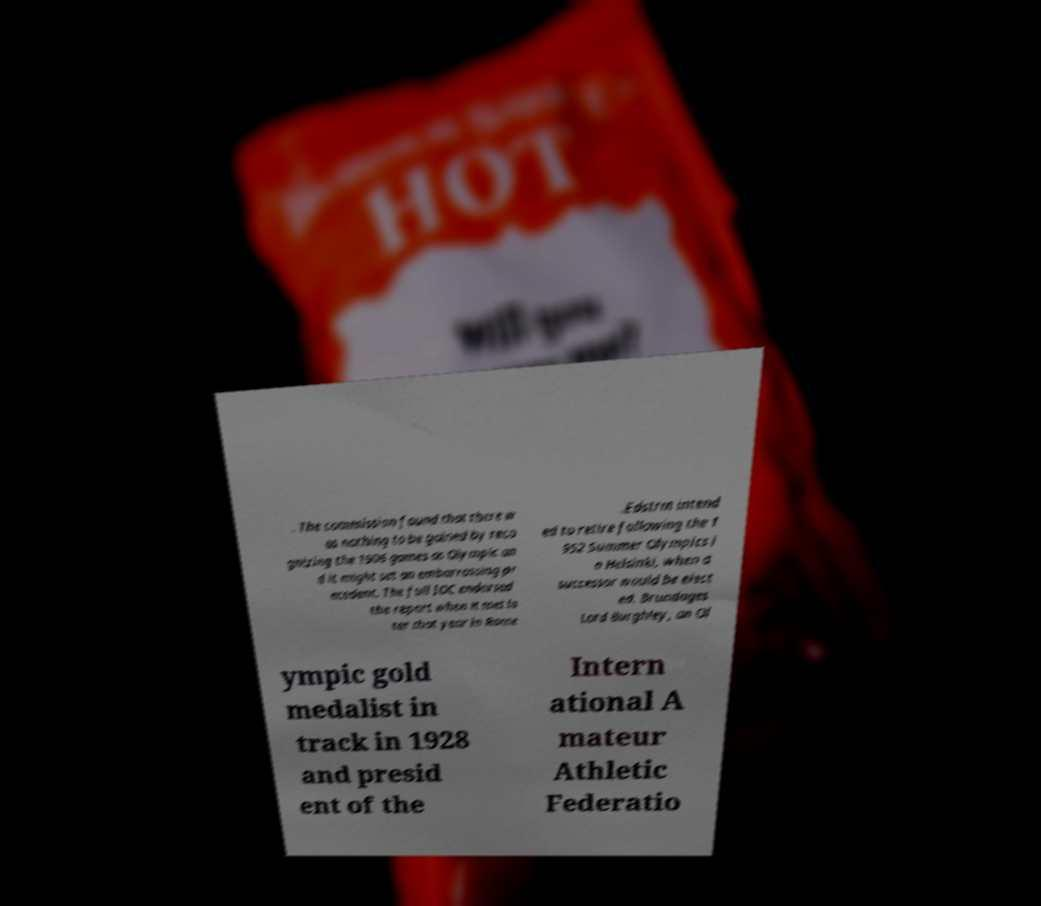Please read and relay the text visible in this image. What does it say? . The commission found that there w as nothing to be gained by reco gnizing the 1906 games as Olympic an d it might set an embarrassing pr ecedent. The full IOC endorsed the report when it met la ter that year in Rome .Edstrm intend ed to retire following the 1 952 Summer Olympics i n Helsinki, when a successor would be elect ed. Brundages Lord Burghley, an Ol ympic gold medalist in track in 1928 and presid ent of the Intern ational A mateur Athletic Federatio 